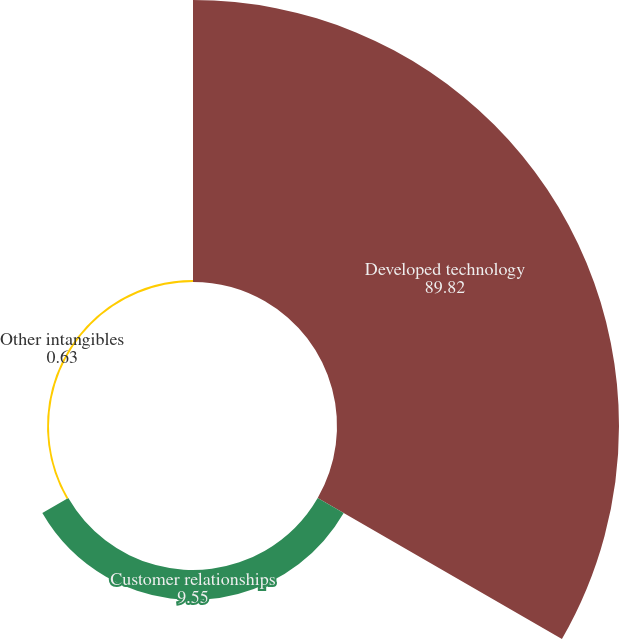<chart> <loc_0><loc_0><loc_500><loc_500><pie_chart><fcel>Developed technology<fcel>Customer relationships<fcel>Other intangibles<nl><fcel>89.82%<fcel>9.55%<fcel>0.63%<nl></chart> 